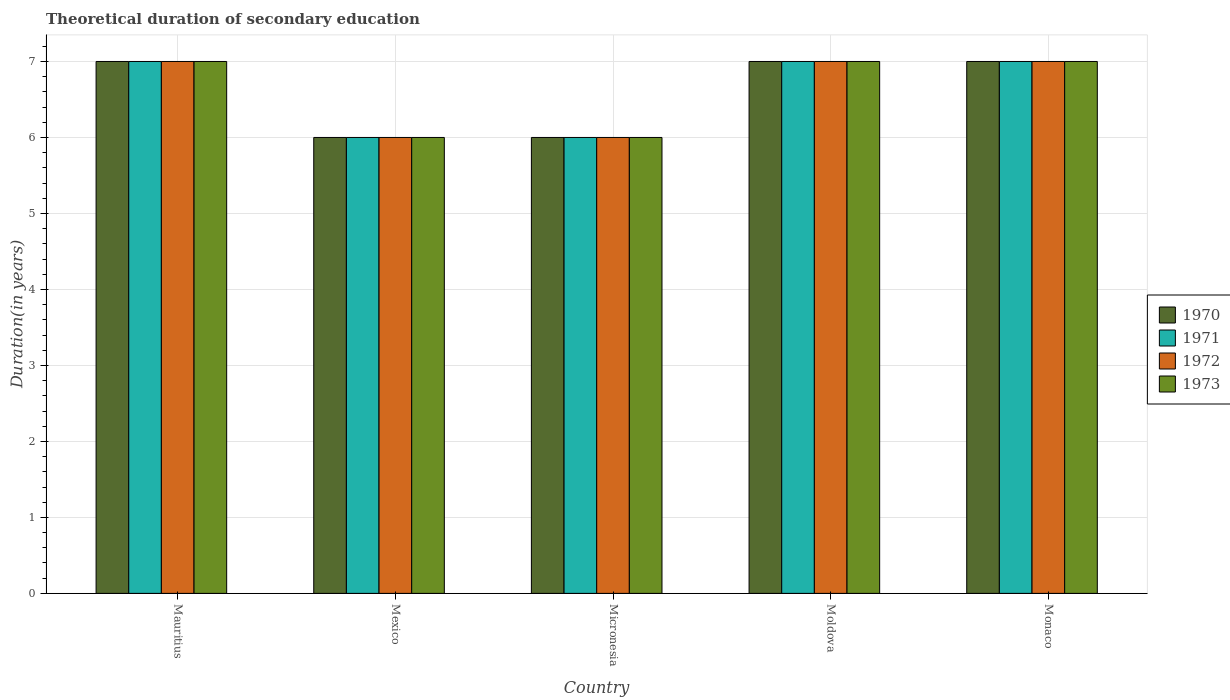How many groups of bars are there?
Provide a succinct answer. 5. Are the number of bars on each tick of the X-axis equal?
Keep it short and to the point. Yes. How many bars are there on the 3rd tick from the right?
Provide a succinct answer. 4. What is the label of the 1st group of bars from the left?
Your answer should be very brief. Mauritius. In which country was the total theoretical duration of secondary education in 1973 maximum?
Provide a succinct answer. Mauritius. In which country was the total theoretical duration of secondary education in 1972 minimum?
Offer a terse response. Mexico. What is the difference between the total theoretical duration of secondary education in 1972 in Moldova and the total theoretical duration of secondary education in 1970 in Mexico?
Provide a short and direct response. 1. What is the average total theoretical duration of secondary education in 1972 per country?
Make the answer very short. 6.6. In how many countries, is the total theoretical duration of secondary education in 1970 greater than 6.6 years?
Ensure brevity in your answer.  3. What is the ratio of the total theoretical duration of secondary education in 1970 in Micronesia to that in Moldova?
Offer a very short reply. 0.86. Is the total theoretical duration of secondary education in 1972 in Mexico less than that in Monaco?
Your answer should be compact. Yes. Is the difference between the total theoretical duration of secondary education in 1972 in Micronesia and Monaco greater than the difference between the total theoretical duration of secondary education in 1970 in Micronesia and Monaco?
Offer a terse response. No. Is the sum of the total theoretical duration of secondary education in 1971 in Mauritius and Mexico greater than the maximum total theoretical duration of secondary education in 1970 across all countries?
Your answer should be compact. Yes. Is it the case that in every country, the sum of the total theoretical duration of secondary education in 1970 and total theoretical duration of secondary education in 1973 is greater than the sum of total theoretical duration of secondary education in 1971 and total theoretical duration of secondary education in 1972?
Ensure brevity in your answer.  No. What does the 2nd bar from the left in Micronesia represents?
Make the answer very short. 1971. What does the 3rd bar from the right in Mauritius represents?
Provide a short and direct response. 1971. How many countries are there in the graph?
Your response must be concise. 5. Where does the legend appear in the graph?
Offer a very short reply. Center right. How are the legend labels stacked?
Your response must be concise. Vertical. What is the title of the graph?
Keep it short and to the point. Theoretical duration of secondary education. What is the label or title of the Y-axis?
Your response must be concise. Duration(in years). What is the Duration(in years) of 1971 in Mauritius?
Your response must be concise. 7. What is the Duration(in years) of 1972 in Mauritius?
Make the answer very short. 7. What is the Duration(in years) of 1970 in Mexico?
Provide a succinct answer. 6. What is the Duration(in years) of 1972 in Mexico?
Provide a succinct answer. 6. What is the Duration(in years) of 1973 in Mexico?
Offer a very short reply. 6. What is the Duration(in years) in 1971 in Micronesia?
Your answer should be compact. 6. What is the Duration(in years) of 1972 in Micronesia?
Ensure brevity in your answer.  6. What is the Duration(in years) of 1973 in Micronesia?
Keep it short and to the point. 6. What is the Duration(in years) in 1972 in Moldova?
Make the answer very short. 7. What is the Duration(in years) of 1970 in Monaco?
Your answer should be very brief. 7. What is the Duration(in years) in 1971 in Monaco?
Your answer should be compact. 7. What is the Duration(in years) in 1972 in Monaco?
Give a very brief answer. 7. What is the Duration(in years) of 1973 in Monaco?
Ensure brevity in your answer.  7. Across all countries, what is the maximum Duration(in years) of 1972?
Offer a very short reply. 7. Across all countries, what is the maximum Duration(in years) of 1973?
Ensure brevity in your answer.  7. Across all countries, what is the minimum Duration(in years) of 1970?
Give a very brief answer. 6. Across all countries, what is the minimum Duration(in years) of 1971?
Your answer should be compact. 6. What is the total Duration(in years) of 1971 in the graph?
Provide a short and direct response. 33. What is the total Duration(in years) in 1972 in the graph?
Your answer should be compact. 33. What is the total Duration(in years) in 1973 in the graph?
Your answer should be very brief. 33. What is the difference between the Duration(in years) of 1970 in Mauritius and that in Mexico?
Provide a succinct answer. 1. What is the difference between the Duration(in years) of 1972 in Mauritius and that in Mexico?
Provide a succinct answer. 1. What is the difference between the Duration(in years) of 1973 in Mauritius and that in Mexico?
Give a very brief answer. 1. What is the difference between the Duration(in years) of 1973 in Mauritius and that in Micronesia?
Offer a terse response. 1. What is the difference between the Duration(in years) in 1970 in Mauritius and that in Moldova?
Offer a very short reply. 0. What is the difference between the Duration(in years) in 1973 in Mauritius and that in Moldova?
Your answer should be compact. 0. What is the difference between the Duration(in years) of 1973 in Mauritius and that in Monaco?
Offer a very short reply. 0. What is the difference between the Duration(in years) in 1970 in Mexico and that in Moldova?
Provide a succinct answer. -1. What is the difference between the Duration(in years) in 1973 in Mexico and that in Moldova?
Ensure brevity in your answer.  -1. What is the difference between the Duration(in years) in 1973 in Mexico and that in Monaco?
Keep it short and to the point. -1. What is the difference between the Duration(in years) in 1970 in Micronesia and that in Moldova?
Give a very brief answer. -1. What is the difference between the Duration(in years) of 1971 in Micronesia and that in Moldova?
Offer a very short reply. -1. What is the difference between the Duration(in years) in 1972 in Micronesia and that in Moldova?
Your response must be concise. -1. What is the difference between the Duration(in years) of 1973 in Micronesia and that in Moldova?
Your response must be concise. -1. What is the difference between the Duration(in years) in 1971 in Micronesia and that in Monaco?
Your response must be concise. -1. What is the difference between the Duration(in years) of 1972 in Micronesia and that in Monaco?
Your response must be concise. -1. What is the difference between the Duration(in years) of 1973 in Micronesia and that in Monaco?
Provide a short and direct response. -1. What is the difference between the Duration(in years) in 1970 in Moldova and that in Monaco?
Your answer should be compact. 0. What is the difference between the Duration(in years) in 1971 in Moldova and that in Monaco?
Provide a succinct answer. 0. What is the difference between the Duration(in years) in 1972 in Moldova and that in Monaco?
Offer a very short reply. 0. What is the difference between the Duration(in years) in 1973 in Moldova and that in Monaco?
Offer a terse response. 0. What is the difference between the Duration(in years) in 1970 in Mauritius and the Duration(in years) in 1971 in Mexico?
Ensure brevity in your answer.  1. What is the difference between the Duration(in years) in 1970 in Mauritius and the Duration(in years) in 1972 in Mexico?
Make the answer very short. 1. What is the difference between the Duration(in years) in 1970 in Mauritius and the Duration(in years) in 1971 in Micronesia?
Your response must be concise. 1. What is the difference between the Duration(in years) of 1970 in Mauritius and the Duration(in years) of 1973 in Micronesia?
Provide a short and direct response. 1. What is the difference between the Duration(in years) in 1971 in Mauritius and the Duration(in years) in 1972 in Micronesia?
Make the answer very short. 1. What is the difference between the Duration(in years) of 1971 in Mauritius and the Duration(in years) of 1973 in Micronesia?
Your response must be concise. 1. What is the difference between the Duration(in years) of 1971 in Mauritius and the Duration(in years) of 1972 in Moldova?
Keep it short and to the point. 0. What is the difference between the Duration(in years) of 1972 in Mauritius and the Duration(in years) of 1973 in Moldova?
Keep it short and to the point. 0. What is the difference between the Duration(in years) of 1970 in Mauritius and the Duration(in years) of 1972 in Monaco?
Keep it short and to the point. 0. What is the difference between the Duration(in years) in 1972 in Mauritius and the Duration(in years) in 1973 in Monaco?
Make the answer very short. 0. What is the difference between the Duration(in years) of 1970 in Mexico and the Duration(in years) of 1971 in Micronesia?
Your response must be concise. 0. What is the difference between the Duration(in years) of 1971 in Mexico and the Duration(in years) of 1972 in Micronesia?
Offer a very short reply. 0. What is the difference between the Duration(in years) of 1971 in Mexico and the Duration(in years) of 1973 in Micronesia?
Make the answer very short. 0. What is the difference between the Duration(in years) of 1972 in Mexico and the Duration(in years) of 1973 in Micronesia?
Offer a very short reply. 0. What is the difference between the Duration(in years) of 1970 in Mexico and the Duration(in years) of 1973 in Moldova?
Your response must be concise. -1. What is the difference between the Duration(in years) of 1971 in Mexico and the Duration(in years) of 1973 in Moldova?
Ensure brevity in your answer.  -1. What is the difference between the Duration(in years) of 1972 in Mexico and the Duration(in years) of 1973 in Moldova?
Provide a succinct answer. -1. What is the difference between the Duration(in years) in 1970 in Mexico and the Duration(in years) in 1973 in Monaco?
Your response must be concise. -1. What is the difference between the Duration(in years) in 1972 in Mexico and the Duration(in years) in 1973 in Monaco?
Offer a terse response. -1. What is the difference between the Duration(in years) of 1970 in Micronesia and the Duration(in years) of 1971 in Moldova?
Provide a succinct answer. -1. What is the difference between the Duration(in years) of 1970 in Micronesia and the Duration(in years) of 1972 in Moldova?
Your answer should be compact. -1. What is the difference between the Duration(in years) in 1972 in Micronesia and the Duration(in years) in 1973 in Moldova?
Your answer should be very brief. -1. What is the difference between the Duration(in years) of 1970 in Micronesia and the Duration(in years) of 1972 in Monaco?
Make the answer very short. -1. What is the difference between the Duration(in years) in 1971 in Micronesia and the Duration(in years) in 1972 in Monaco?
Provide a short and direct response. -1. What is the difference between the Duration(in years) of 1971 in Micronesia and the Duration(in years) of 1973 in Monaco?
Offer a very short reply. -1. What is the difference between the Duration(in years) in 1970 in Moldova and the Duration(in years) in 1971 in Monaco?
Your response must be concise. 0. What is the difference between the Duration(in years) of 1971 in Moldova and the Duration(in years) of 1972 in Monaco?
Your answer should be very brief. 0. What is the difference between the Duration(in years) in 1971 in Moldova and the Duration(in years) in 1973 in Monaco?
Offer a terse response. 0. What is the average Duration(in years) of 1971 per country?
Provide a succinct answer. 6.6. What is the average Duration(in years) of 1972 per country?
Provide a succinct answer. 6.6. What is the average Duration(in years) of 1973 per country?
Your answer should be compact. 6.6. What is the difference between the Duration(in years) of 1972 and Duration(in years) of 1973 in Mauritius?
Your answer should be compact. 0. What is the difference between the Duration(in years) of 1970 and Duration(in years) of 1973 in Mexico?
Your answer should be very brief. 0. What is the difference between the Duration(in years) of 1971 and Duration(in years) of 1973 in Mexico?
Your answer should be compact. 0. What is the difference between the Duration(in years) of 1972 and Duration(in years) of 1973 in Mexico?
Make the answer very short. 0. What is the difference between the Duration(in years) of 1970 and Duration(in years) of 1972 in Micronesia?
Make the answer very short. 0. What is the difference between the Duration(in years) in 1970 and Duration(in years) in 1973 in Micronesia?
Provide a succinct answer. 0. What is the difference between the Duration(in years) of 1971 and Duration(in years) of 1973 in Micronesia?
Your answer should be compact. 0. What is the difference between the Duration(in years) of 1970 and Duration(in years) of 1972 in Moldova?
Provide a succinct answer. 0. What is the difference between the Duration(in years) of 1971 and Duration(in years) of 1973 in Moldova?
Offer a terse response. 0. What is the difference between the Duration(in years) in 1972 and Duration(in years) in 1973 in Moldova?
Your response must be concise. 0. What is the difference between the Duration(in years) of 1970 and Duration(in years) of 1971 in Monaco?
Provide a succinct answer. 0. What is the difference between the Duration(in years) of 1970 and Duration(in years) of 1972 in Monaco?
Offer a terse response. 0. What is the ratio of the Duration(in years) in 1970 in Mauritius to that in Mexico?
Ensure brevity in your answer.  1.17. What is the ratio of the Duration(in years) of 1971 in Mauritius to that in Mexico?
Your response must be concise. 1.17. What is the ratio of the Duration(in years) in 1970 in Mauritius to that in Micronesia?
Make the answer very short. 1.17. What is the ratio of the Duration(in years) of 1971 in Mauritius to that in Micronesia?
Provide a short and direct response. 1.17. What is the ratio of the Duration(in years) of 1972 in Mauritius to that in Micronesia?
Offer a terse response. 1.17. What is the ratio of the Duration(in years) in 1972 in Mauritius to that in Moldova?
Offer a very short reply. 1. What is the ratio of the Duration(in years) in 1971 in Mauritius to that in Monaco?
Your answer should be very brief. 1. What is the ratio of the Duration(in years) of 1970 in Mexico to that in Moldova?
Give a very brief answer. 0.86. What is the ratio of the Duration(in years) in 1972 in Mexico to that in Moldova?
Your answer should be very brief. 0.86. What is the ratio of the Duration(in years) of 1971 in Mexico to that in Monaco?
Ensure brevity in your answer.  0.86. What is the ratio of the Duration(in years) in 1973 in Mexico to that in Monaco?
Your answer should be very brief. 0.86. What is the ratio of the Duration(in years) of 1970 in Micronesia to that in Moldova?
Your answer should be very brief. 0.86. What is the ratio of the Duration(in years) of 1971 in Micronesia to that in Moldova?
Make the answer very short. 0.86. What is the ratio of the Duration(in years) of 1973 in Micronesia to that in Moldova?
Provide a short and direct response. 0.86. What is the ratio of the Duration(in years) of 1970 in Micronesia to that in Monaco?
Provide a succinct answer. 0.86. What is the ratio of the Duration(in years) in 1971 in Micronesia to that in Monaco?
Provide a short and direct response. 0.86. What is the ratio of the Duration(in years) of 1972 in Micronesia to that in Monaco?
Your answer should be compact. 0.86. What is the ratio of the Duration(in years) in 1970 in Moldova to that in Monaco?
Keep it short and to the point. 1. What is the ratio of the Duration(in years) in 1971 in Moldova to that in Monaco?
Ensure brevity in your answer.  1. What is the difference between the highest and the second highest Duration(in years) in 1972?
Provide a short and direct response. 0. What is the difference between the highest and the second highest Duration(in years) of 1973?
Give a very brief answer. 0. What is the difference between the highest and the lowest Duration(in years) in 1970?
Offer a terse response. 1. What is the difference between the highest and the lowest Duration(in years) of 1971?
Keep it short and to the point. 1. What is the difference between the highest and the lowest Duration(in years) in 1972?
Your answer should be very brief. 1. What is the difference between the highest and the lowest Duration(in years) of 1973?
Make the answer very short. 1. 